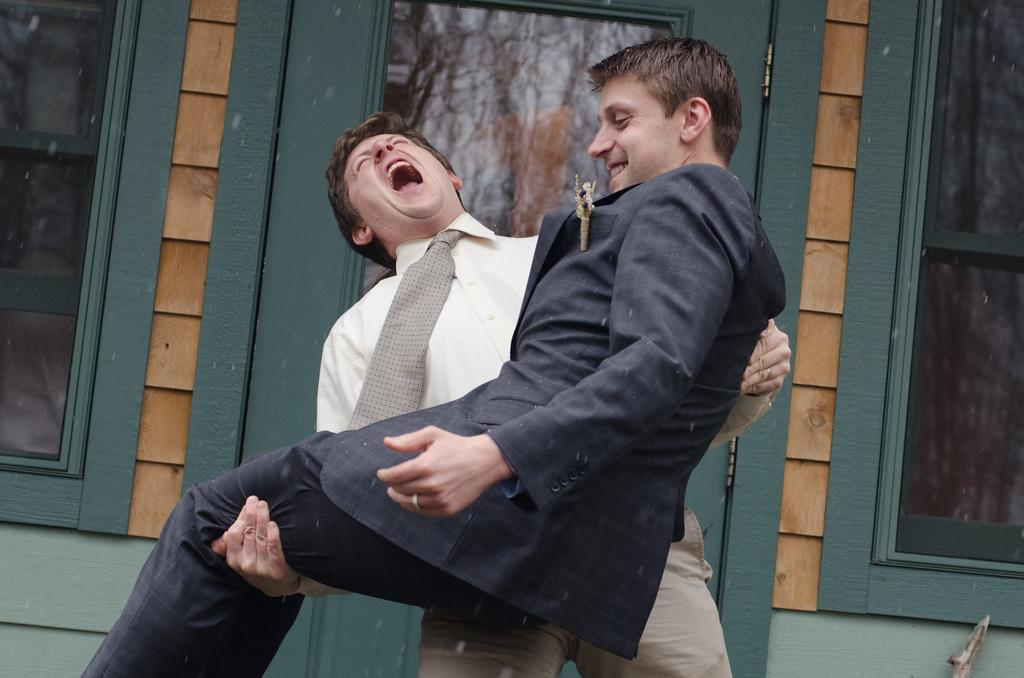What is the main subject of the image? There is a man in the image. What is the man doing in the image? The man is lifting another man. What can be seen in the background of the image? There is a house in the background of the image. What type of print can be seen on the man's shirt in the image? There is no information about the man's shirt or any print on it in the provided facts. 